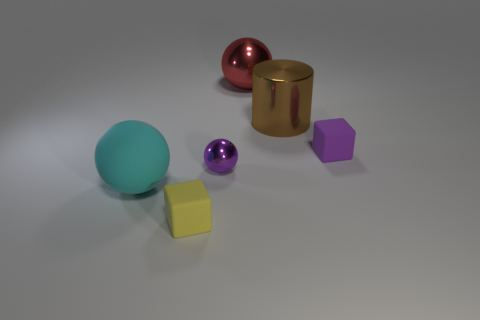Subtract all big spheres. How many spheres are left? 1 Add 2 large green matte cylinders. How many objects exist? 8 Subtract all cylinders. How many objects are left? 5 Subtract all blue spheres. Subtract all cyan cylinders. How many spheres are left? 3 Subtract all purple metallic cylinders. Subtract all spheres. How many objects are left? 3 Add 1 red things. How many red things are left? 2 Add 3 yellow metal blocks. How many yellow metal blocks exist? 3 Subtract 1 cyan spheres. How many objects are left? 5 